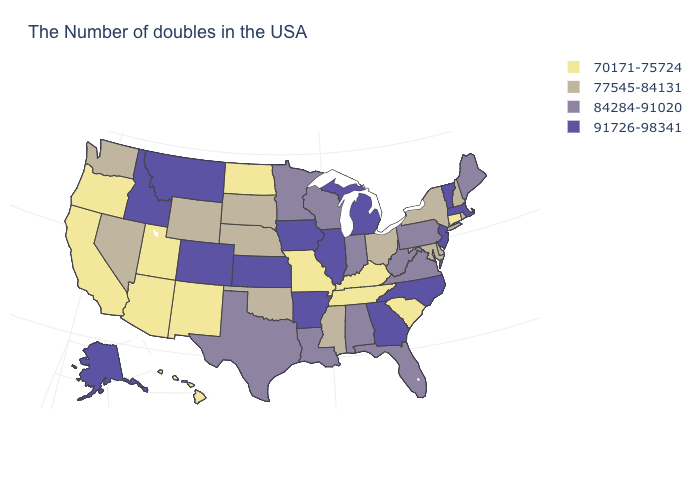Among the states that border Georgia , does South Carolina have the highest value?
Short answer required. No. What is the value of New Jersey?
Short answer required. 91726-98341. Name the states that have a value in the range 91726-98341?
Answer briefly. Massachusetts, Vermont, New Jersey, North Carolina, Georgia, Michigan, Illinois, Arkansas, Iowa, Kansas, Colorado, Montana, Idaho, Alaska. Among the states that border South Carolina , which have the highest value?
Keep it brief. North Carolina, Georgia. Does Mississippi have a lower value than Wisconsin?
Concise answer only. Yes. Which states have the lowest value in the USA?
Short answer required. Connecticut, South Carolina, Kentucky, Tennessee, Missouri, North Dakota, New Mexico, Utah, Arizona, California, Oregon, Hawaii. Does Oklahoma have a higher value than Kentucky?
Be succinct. Yes. Name the states that have a value in the range 77545-84131?
Answer briefly. Rhode Island, New Hampshire, New York, Delaware, Maryland, Ohio, Mississippi, Nebraska, Oklahoma, South Dakota, Wyoming, Nevada, Washington. Among the states that border Pennsylvania , which have the highest value?
Answer briefly. New Jersey. Is the legend a continuous bar?
Keep it brief. No. How many symbols are there in the legend?
Answer briefly. 4. What is the lowest value in states that border Minnesota?
Write a very short answer. 70171-75724. Does Nebraska have the lowest value in the MidWest?
Keep it brief. No. What is the value of Vermont?
Quick response, please. 91726-98341. 